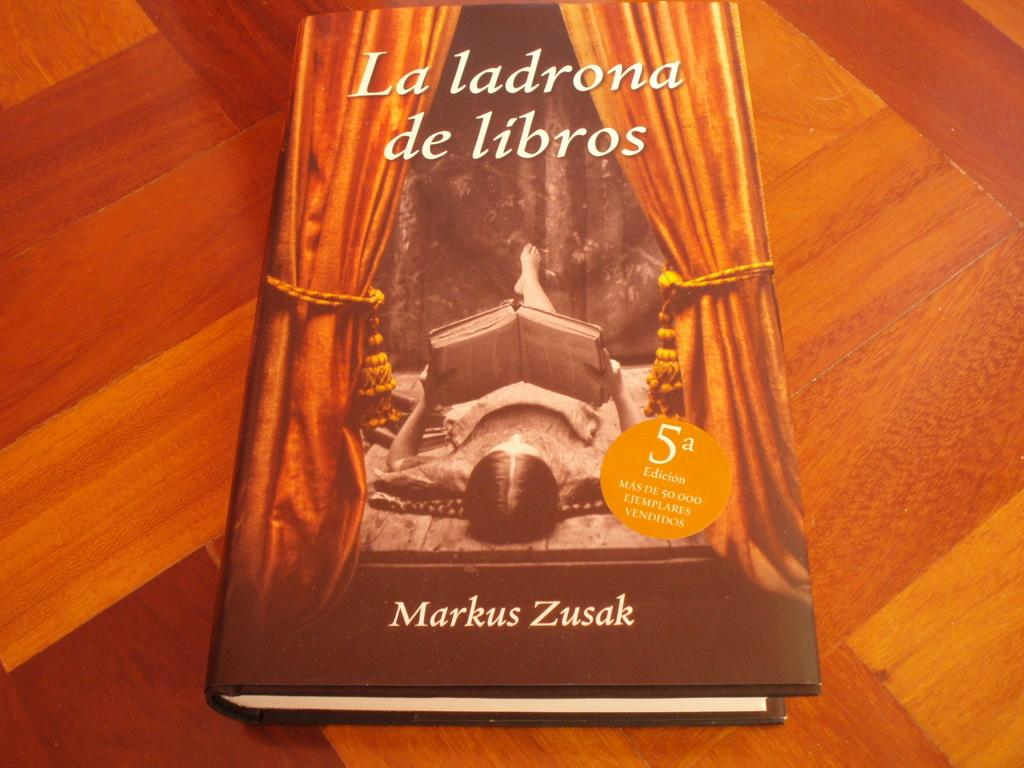What object is on the table in the image? There is a book on the table. What is the woman in the image doing? The woman is reading a book. Where is the woman located in relation to the table? The woman is at the top of the table. What type of window treatment is present in the image? There are curtains present. What type of cherry is the woman eating while reading the book? There is no cherry present in the image; the woman is only reading a book. How much butter is visible on the table in the image? There is no butter present in the image. 